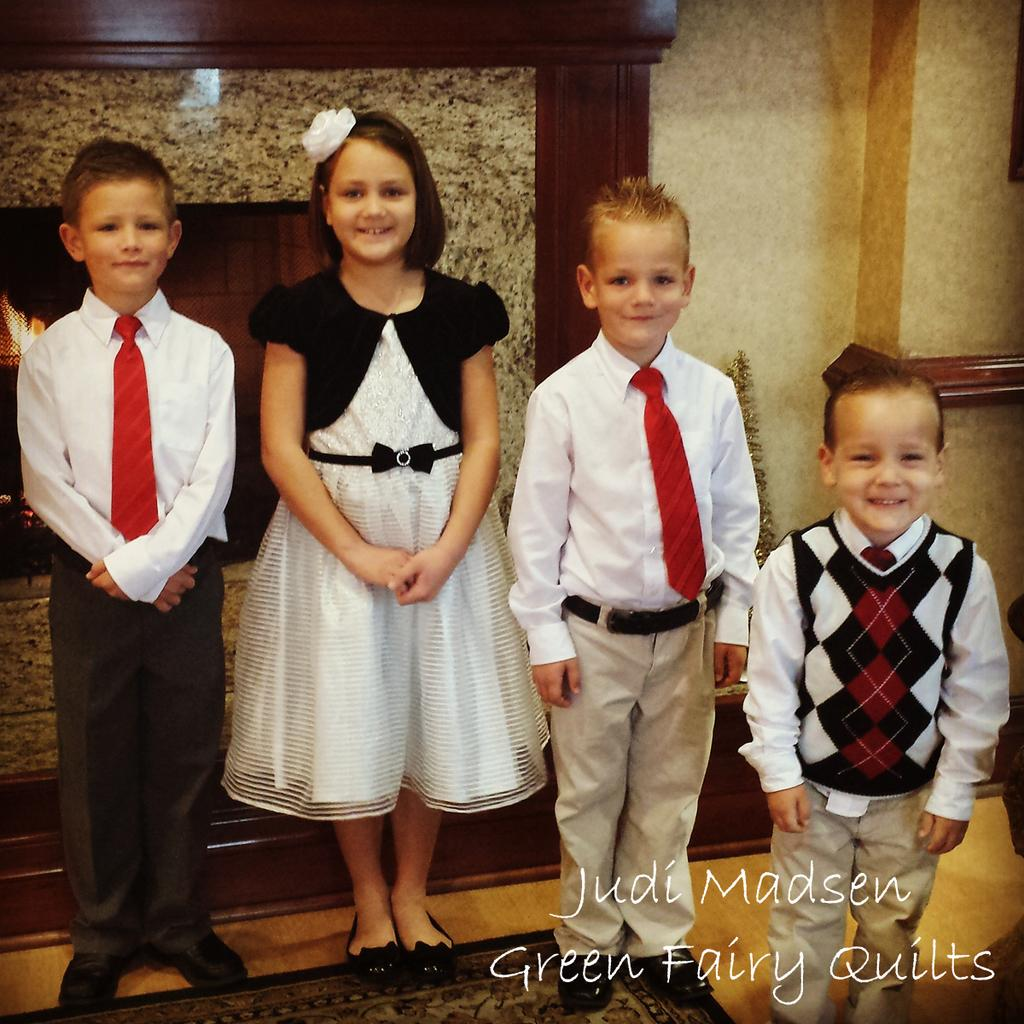How many children are in the image? There are three boys and a girl in the image, making a total of four children. What are the children doing in the image? The children are standing in the image. What is on the floor in the image? There is a mat on the floor in the image. What can be seen at the bottom of the image? There is text at the bottom of the image. What architectural feature is present in the image? There is a fireplace in the image. What is the background of the image? There is a wall in the image. What type of net is being used by the children in the image? There is no net present in the image; the children are simply standing. Who is the manager of the children in the image? There is no manager mentioned or depicted in the image. 